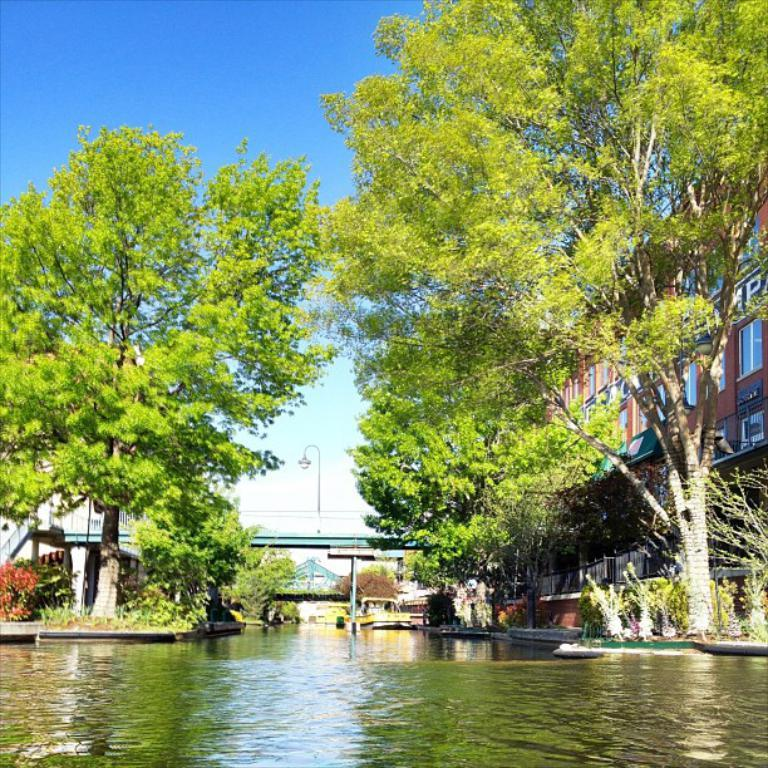What type of structure can be seen in the image? There is a bridge in the image. What type of natural elements are present in the image? There are trees, water, and clouds visible in the image. What type of man-made structures can be seen in the image? There are houses, buildings, and boats in the image. What type of vegetation is present in the image? There are plants in the image. What part of the natural environment is visible in the image? The sky is visible in the image. Where is the volleyball court located in the image? There is no volleyball court present in the image. How does the wind affect the boats in the image? The image does not show any indication of wind, so its effect on the boats cannot be determined. 